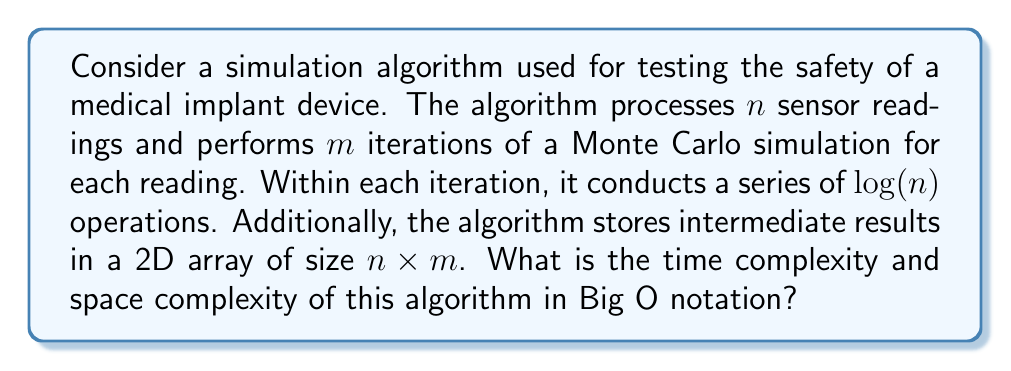Can you solve this math problem? To determine the time and space complexity of this algorithm, let's break it down step by step:

1. Time Complexity:
   a) The algorithm processes $n$ sensor readings.
   b) For each reading, it performs $m$ iterations.
   c) Within each iteration, it conducts $\log(n)$ operations.

   Therefore, the total number of operations is:
   $$n \times m \times \log(n)$$

   This can be expressed in Big O notation as:
   $$O(nm\log(n))$$

2. Space Complexity:
   a) The algorithm stores intermediate results in a 2D array of size $n \times m$.
   b) We assume that the space required for input and output is not considered in space complexity analysis.

   The space required is proportional to:
   $$n \times m$$

   This can be expressed in Big O notation as:
   $$O(nm)$$

It's important to note that in the context of medical device safety testing, the values of $n$ and $m$ could be quite large, potentially leading to significant computational requirements. As a biomedical engineer specializing in medical device design and safety, you would need to consider these complexities when designing and implementing simulation software for safety testing.
Answer: Time Complexity: $O(nm\log(n))$
Space Complexity: $O(nm)$ 